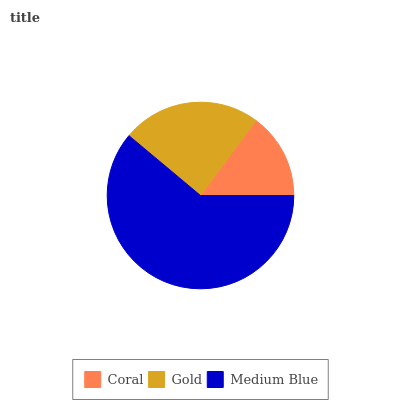Is Coral the minimum?
Answer yes or no. Yes. Is Medium Blue the maximum?
Answer yes or no. Yes. Is Gold the minimum?
Answer yes or no. No. Is Gold the maximum?
Answer yes or no. No. Is Gold greater than Coral?
Answer yes or no. Yes. Is Coral less than Gold?
Answer yes or no. Yes. Is Coral greater than Gold?
Answer yes or no. No. Is Gold less than Coral?
Answer yes or no. No. Is Gold the high median?
Answer yes or no. Yes. Is Gold the low median?
Answer yes or no. Yes. Is Medium Blue the high median?
Answer yes or no. No. Is Coral the low median?
Answer yes or no. No. 